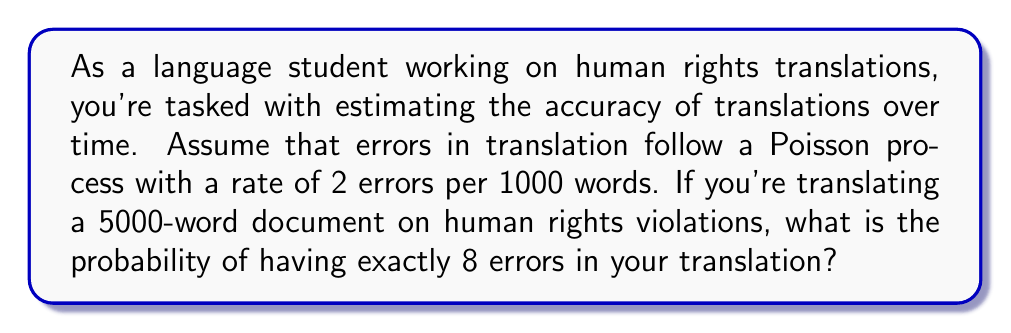Teach me how to tackle this problem. To solve this problem, we'll use the Poisson distribution formula:

$$P(X = k) = \frac{e^{-\lambda} \lambda^k}{k!}$$

Where:
- $X$ is the number of events (errors in this case)
- $k$ is the specific number of events we're interested in (8 errors)
- $\lambda$ is the average number of events in the interval

Step 1: Calculate $\lambda$
The error rate is 2 per 1000 words, and we're translating 5000 words.
$$\lambda = 2 \times \frac{5000}{1000} = 10$$

Step 2: Apply the Poisson distribution formula
$$P(X = 8) = \frac{e^{-10} 10^8}{8!}$$

Step 3: Calculate the result
$$P(X = 8) = \frac{e^{-10} 10^8}{40320} \approx 0.1126$$

Step 4: Convert to percentage
0.1126 × 100% ≈ 11.26%
Answer: 11.26% 